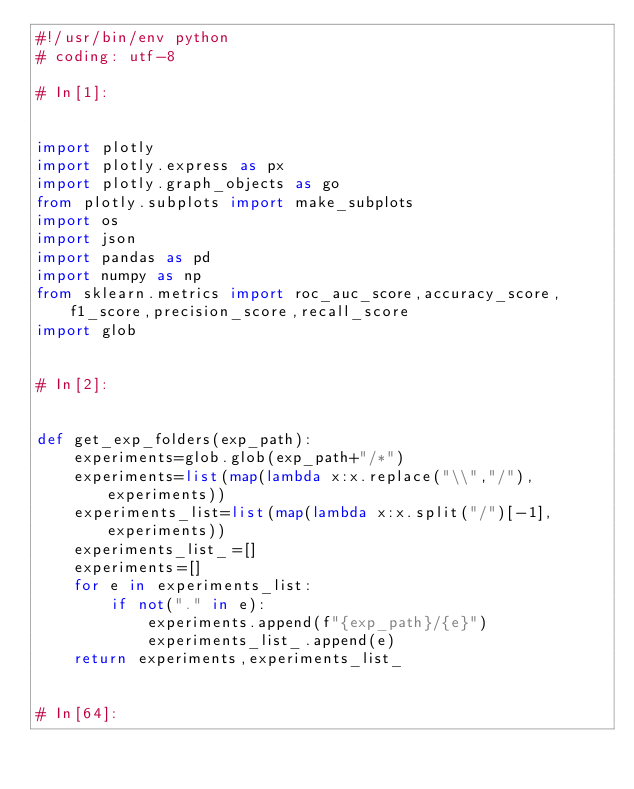Convert code to text. <code><loc_0><loc_0><loc_500><loc_500><_Python_>#!/usr/bin/env python
# coding: utf-8

# In[1]:


import plotly
import plotly.express as px
import plotly.graph_objects as go
from plotly.subplots import make_subplots
import os
import json
import pandas as pd
import numpy as np
from sklearn.metrics import roc_auc_score,accuracy_score,f1_score,precision_score,recall_score
import glob


# In[2]:


def get_exp_folders(exp_path):
    experiments=glob.glob(exp_path+"/*")
    experiments=list(map(lambda x:x.replace("\\","/"),experiments))
    experiments_list=list(map(lambda x:x.split("/")[-1],experiments))
    experiments_list_=[]
    experiments=[]
    for e in experiments_list:
        if not("." in e):
            experiments.append(f"{exp_path}/{e}")
            experiments_list_.append(e)
    return experiments,experiments_list_


# In[64]:

</code> 